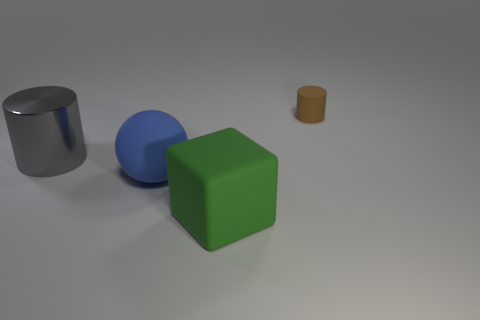Is there any other thing that is made of the same material as the large gray thing?
Ensure brevity in your answer.  No. What material is the cylinder in front of the cylinder on the right side of the cylinder on the left side of the small matte thing?
Give a very brief answer. Metal. What number of other objects are there of the same color as the large cylinder?
Provide a succinct answer. 0. What number of blue things are cubes or small things?
Your answer should be very brief. 0. There is a cylinder in front of the small rubber cylinder; what material is it?
Keep it short and to the point. Metal. Does the cylinder left of the small brown cylinder have the same material as the small brown cylinder?
Make the answer very short. No. There is a gray shiny object; what shape is it?
Your response must be concise. Cylinder. What number of large blue rubber spheres are on the left side of the cylinder that is behind the cylinder in front of the tiny matte cylinder?
Your answer should be very brief. 1. How many other things are there of the same material as the green thing?
Ensure brevity in your answer.  2. What material is the blue ball that is the same size as the green object?
Provide a short and direct response. Rubber. 